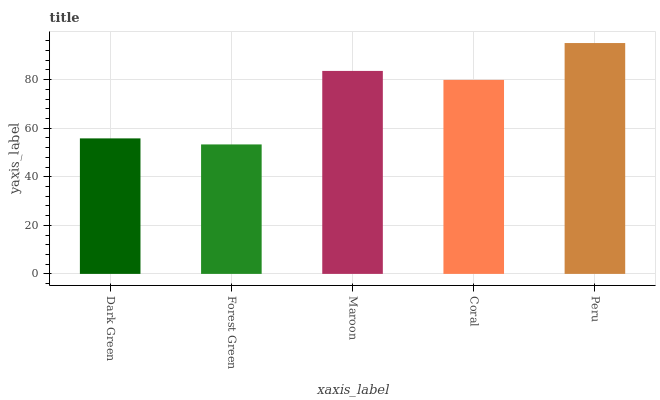Is Maroon the minimum?
Answer yes or no. No. Is Maroon the maximum?
Answer yes or no. No. Is Maroon greater than Forest Green?
Answer yes or no. Yes. Is Forest Green less than Maroon?
Answer yes or no. Yes. Is Forest Green greater than Maroon?
Answer yes or no. No. Is Maroon less than Forest Green?
Answer yes or no. No. Is Coral the high median?
Answer yes or no. Yes. Is Coral the low median?
Answer yes or no. Yes. Is Maroon the high median?
Answer yes or no. No. Is Maroon the low median?
Answer yes or no. No. 